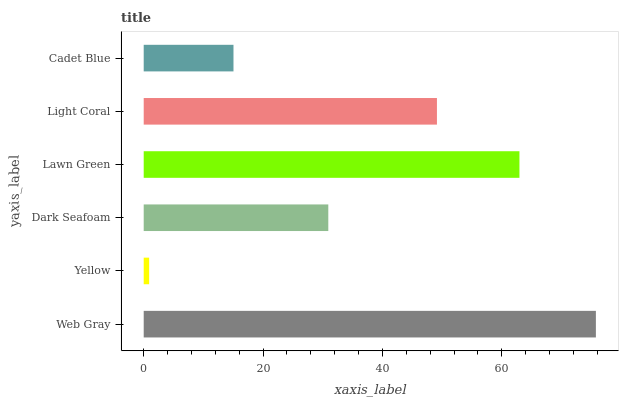Is Yellow the minimum?
Answer yes or no. Yes. Is Web Gray the maximum?
Answer yes or no. Yes. Is Dark Seafoam the minimum?
Answer yes or no. No. Is Dark Seafoam the maximum?
Answer yes or no. No. Is Dark Seafoam greater than Yellow?
Answer yes or no. Yes. Is Yellow less than Dark Seafoam?
Answer yes or no. Yes. Is Yellow greater than Dark Seafoam?
Answer yes or no. No. Is Dark Seafoam less than Yellow?
Answer yes or no. No. Is Light Coral the high median?
Answer yes or no. Yes. Is Dark Seafoam the low median?
Answer yes or no. Yes. Is Dark Seafoam the high median?
Answer yes or no. No. Is Yellow the low median?
Answer yes or no. No. 